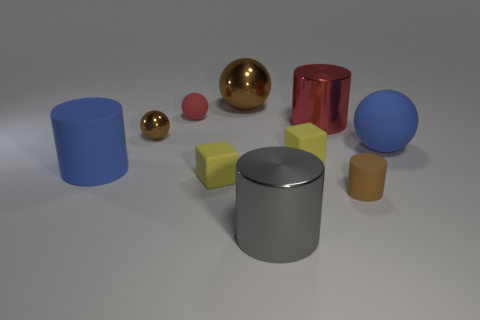Subtract all small matte cylinders. How many cylinders are left? 3 Subtract all brown balls. How many balls are left? 2 Subtract all spheres. Subtract all big red cylinders. How many objects are left? 5 Add 4 brown objects. How many brown objects are left? 7 Add 6 big yellow shiny blocks. How many big yellow shiny blocks exist? 6 Subtract 0 brown blocks. How many objects are left? 10 Subtract all spheres. How many objects are left? 6 Subtract 3 spheres. How many spheres are left? 1 Subtract all green cylinders. Subtract all red spheres. How many cylinders are left? 4 Subtract all purple balls. How many yellow cylinders are left? 0 